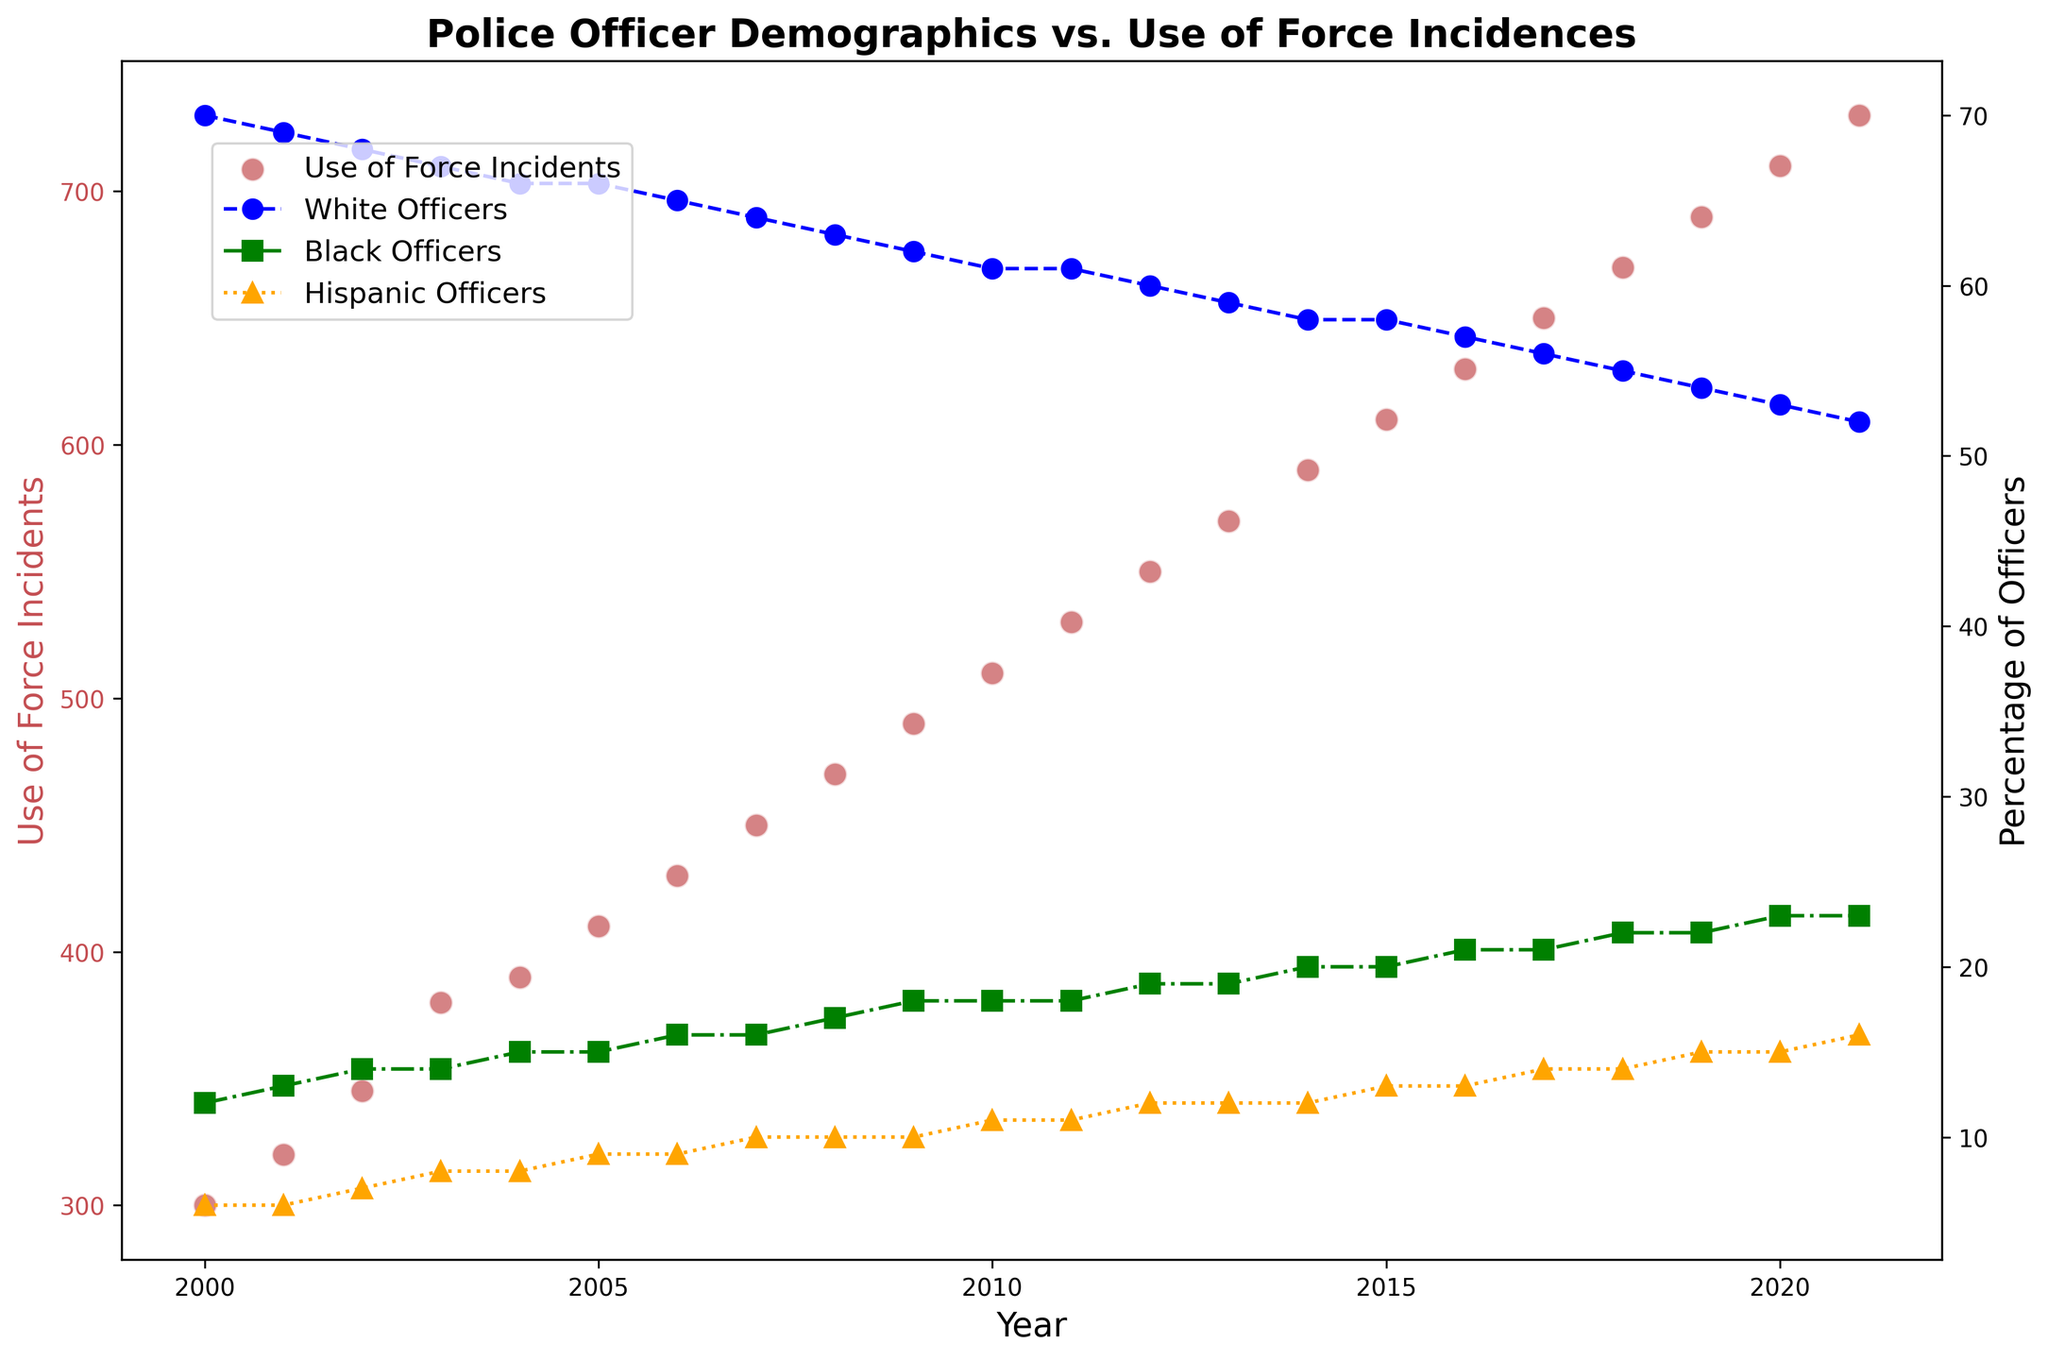What's the trend in the percentage of White officers from 2000 to 2021? To determine the trend in the percentage of White officers, examine the blue line with circle markers. From 2000 (70%) to 2021 (52%), there’s a consistent decrease.
Answer: Decreasing How do the Use of Force Incidents change over time? The red scatter points representing the Use of Force Incidents show an increasing trend from 2000 (300 incidents) to 2021 (730 incidents).
Answer: Increasing Which year has the highest percentage of Hispanic officers? Observe the orange line with triangle markers. In 2021, the percentage is at its highest (16%).
Answer: 2021 Compare the percentage of Black officers and Hispanic officers in 2010? In 2010, the green line (Black officers) is at 18%, and the orange line (Hispanic officers) is at 11%. Thus, the percentage of Black officers is higher.
Answer: Black officers Calculate the average Use of Force Incidents from 2000 to 2005. Sum the incidents from 2000 (300), 2001 (320), 2002 (345), 2003 (380), 2004 (390), to 2005 (410), which equals 2145. Divide by the number of years (6), giving an average of 357.5.
Answer: 357.5 Which year shows the lowest percentage of White Officers? The blue line reaches its lowest point in 2021 at 52%.
Answer: 2021 Describe the trend in the percentage of Black officers from 2000 to 2021. The green line with square markers shows a general increase from 12% in 2000 to 23% in 2021.
Answer: Increasing What is the relationship between Use of Force Incidents and the percentage of White officers? Observing the red scatter points and the blue line, as the percentage of White officers decreases over time, Use of Force Incidents increase.
Answer: Negative correlation Is there any year where all three demographic lines (White, Black, Hispanic) intersect? Checking the plotted lines, no year shows an intersection of all three demographic percentages.
Answer: No How does the percentage of Hispanic officers change from 2000 to 2021? The orange dotted line with triangle markers shows a clear upward trend, starting at 6% in 2000 and increasing to 16% in 2021.
Answer: Increasing 